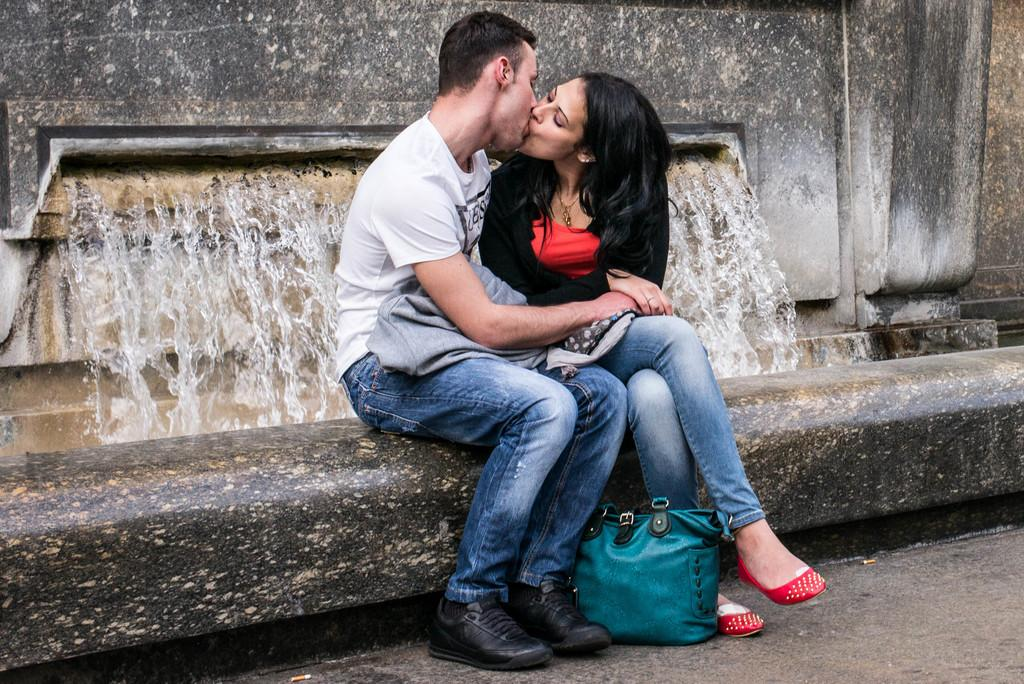What are the two people in the image doing? The two people in the image are kissing. What object can be seen near the couple in the image? There is a carry bag visible in the image. What can be seen in the background of the image? There is a water fountain and a wall in the background of the image. How many dimes are on the wall in the image? There are no dimes present in the image; the wall is part of the background and does not have any coins on it. 